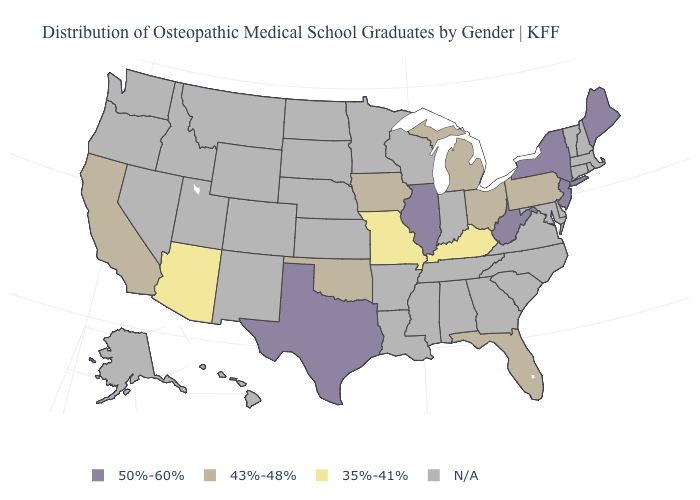Name the states that have a value in the range 35%-41%?
Give a very brief answer. Arizona, Kentucky, Missouri. What is the value of Alaska?
Write a very short answer. N/A. Name the states that have a value in the range N/A?
Keep it brief. Alabama, Alaska, Arkansas, Colorado, Connecticut, Delaware, Georgia, Hawaii, Idaho, Indiana, Kansas, Louisiana, Maryland, Massachusetts, Minnesota, Mississippi, Montana, Nebraska, Nevada, New Hampshire, New Mexico, North Carolina, North Dakota, Oregon, Rhode Island, South Carolina, South Dakota, Tennessee, Utah, Vermont, Virginia, Washington, Wisconsin, Wyoming. Name the states that have a value in the range 43%-48%?
Write a very short answer. California, Florida, Iowa, Michigan, Ohio, Oklahoma, Pennsylvania. Name the states that have a value in the range N/A?
Answer briefly. Alabama, Alaska, Arkansas, Colorado, Connecticut, Delaware, Georgia, Hawaii, Idaho, Indiana, Kansas, Louisiana, Maryland, Massachusetts, Minnesota, Mississippi, Montana, Nebraska, Nevada, New Hampshire, New Mexico, North Carolina, North Dakota, Oregon, Rhode Island, South Carolina, South Dakota, Tennessee, Utah, Vermont, Virginia, Washington, Wisconsin, Wyoming. Does the first symbol in the legend represent the smallest category?
Concise answer only. No. Which states have the lowest value in the MidWest?
Answer briefly. Missouri. What is the value of Wisconsin?
Quick response, please. N/A. What is the highest value in the USA?
Write a very short answer. 50%-60%. Which states have the lowest value in the USA?
Write a very short answer. Arizona, Kentucky, Missouri. Which states have the lowest value in the USA?
Quick response, please. Arizona, Kentucky, Missouri. Among the states that border Maryland , which have the lowest value?
Write a very short answer. Pennsylvania. Name the states that have a value in the range 50%-60%?
Be succinct. Illinois, Maine, New Jersey, New York, Texas, West Virginia. What is the lowest value in states that border California?
Write a very short answer. 35%-41%. What is the value of Illinois?
Concise answer only. 50%-60%. 